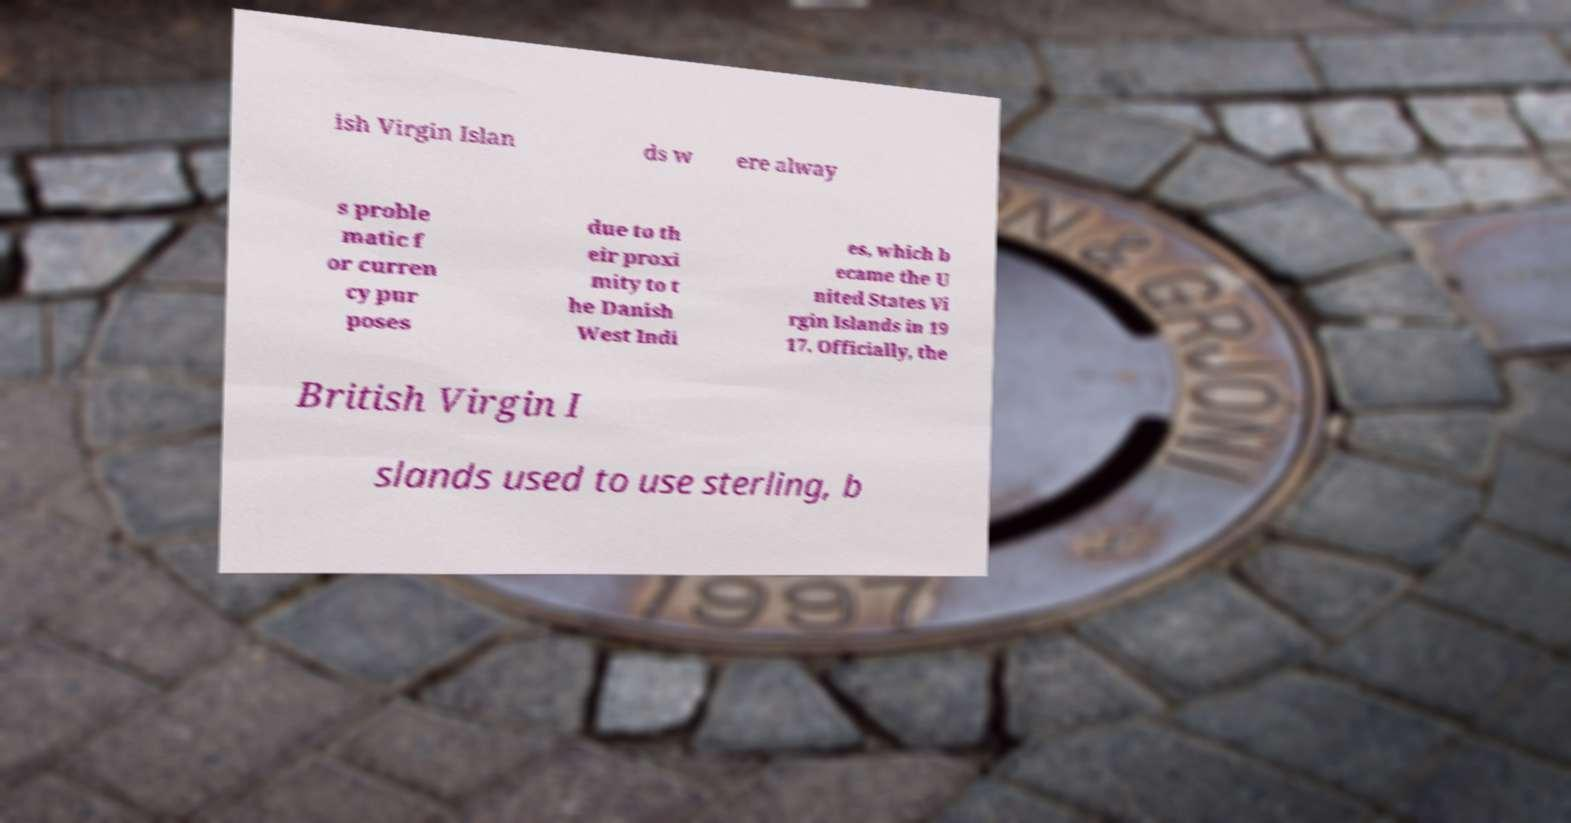For documentation purposes, I need the text within this image transcribed. Could you provide that? ish Virgin Islan ds w ere alway s proble matic f or curren cy pur poses due to th eir proxi mity to t he Danish West Indi es, which b ecame the U nited States Vi rgin Islands in 19 17. Officially, the British Virgin I slands used to use sterling, b 